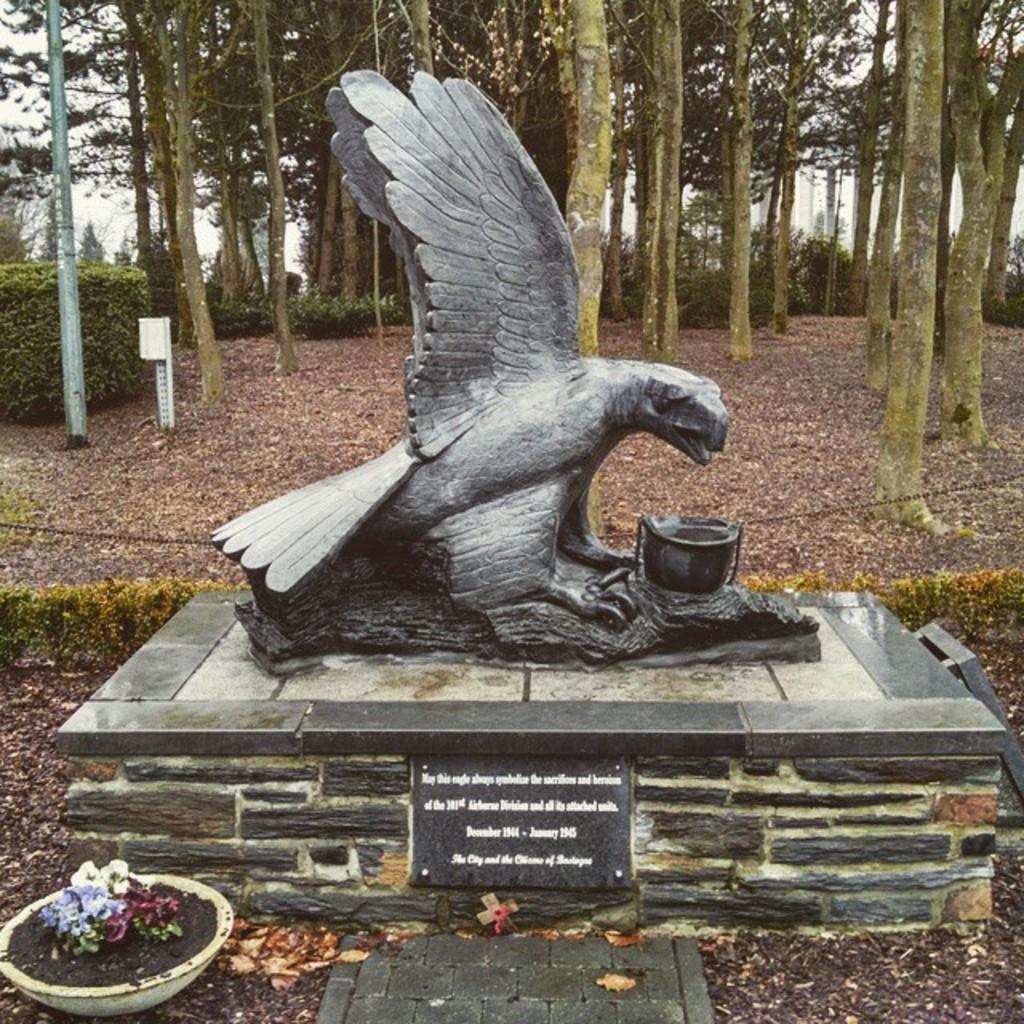Could you give a brief overview of what you see in this image? In this image I can see a memorial in the center of the image with a plate with some text and there is a potted plant. I can see trees, plants and an electric pole behind the memorial. 